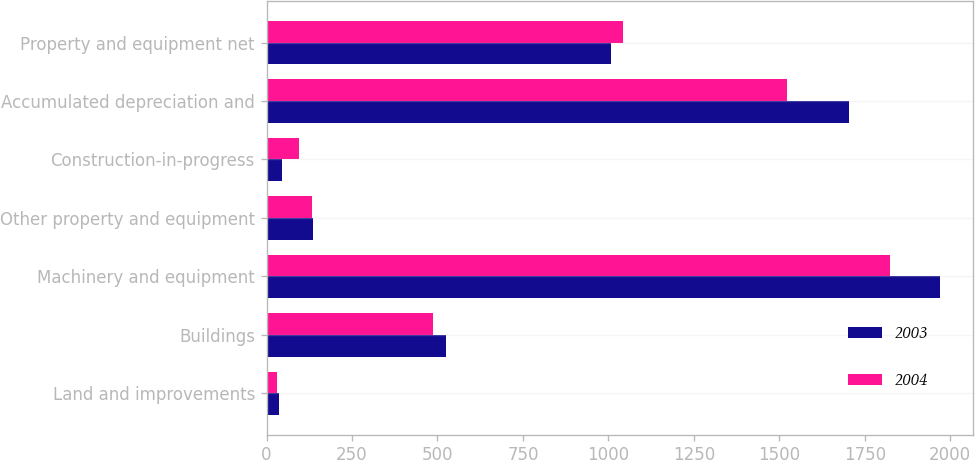<chart> <loc_0><loc_0><loc_500><loc_500><stacked_bar_chart><ecel><fcel>Land and improvements<fcel>Buildings<fcel>Machinery and equipment<fcel>Other property and equipment<fcel>Construction-in-progress<fcel>Accumulated depreciation and<fcel>Property and equipment net<nl><fcel>2003<fcel>35.5<fcel>524.9<fcel>1969.6<fcel>137<fcel>46.5<fcel>1704.9<fcel>1008.6<nl><fcel>2004<fcel>31.9<fcel>485.5<fcel>1823.6<fcel>131.7<fcel>93.5<fcel>1523.8<fcel>1042.4<nl></chart> 